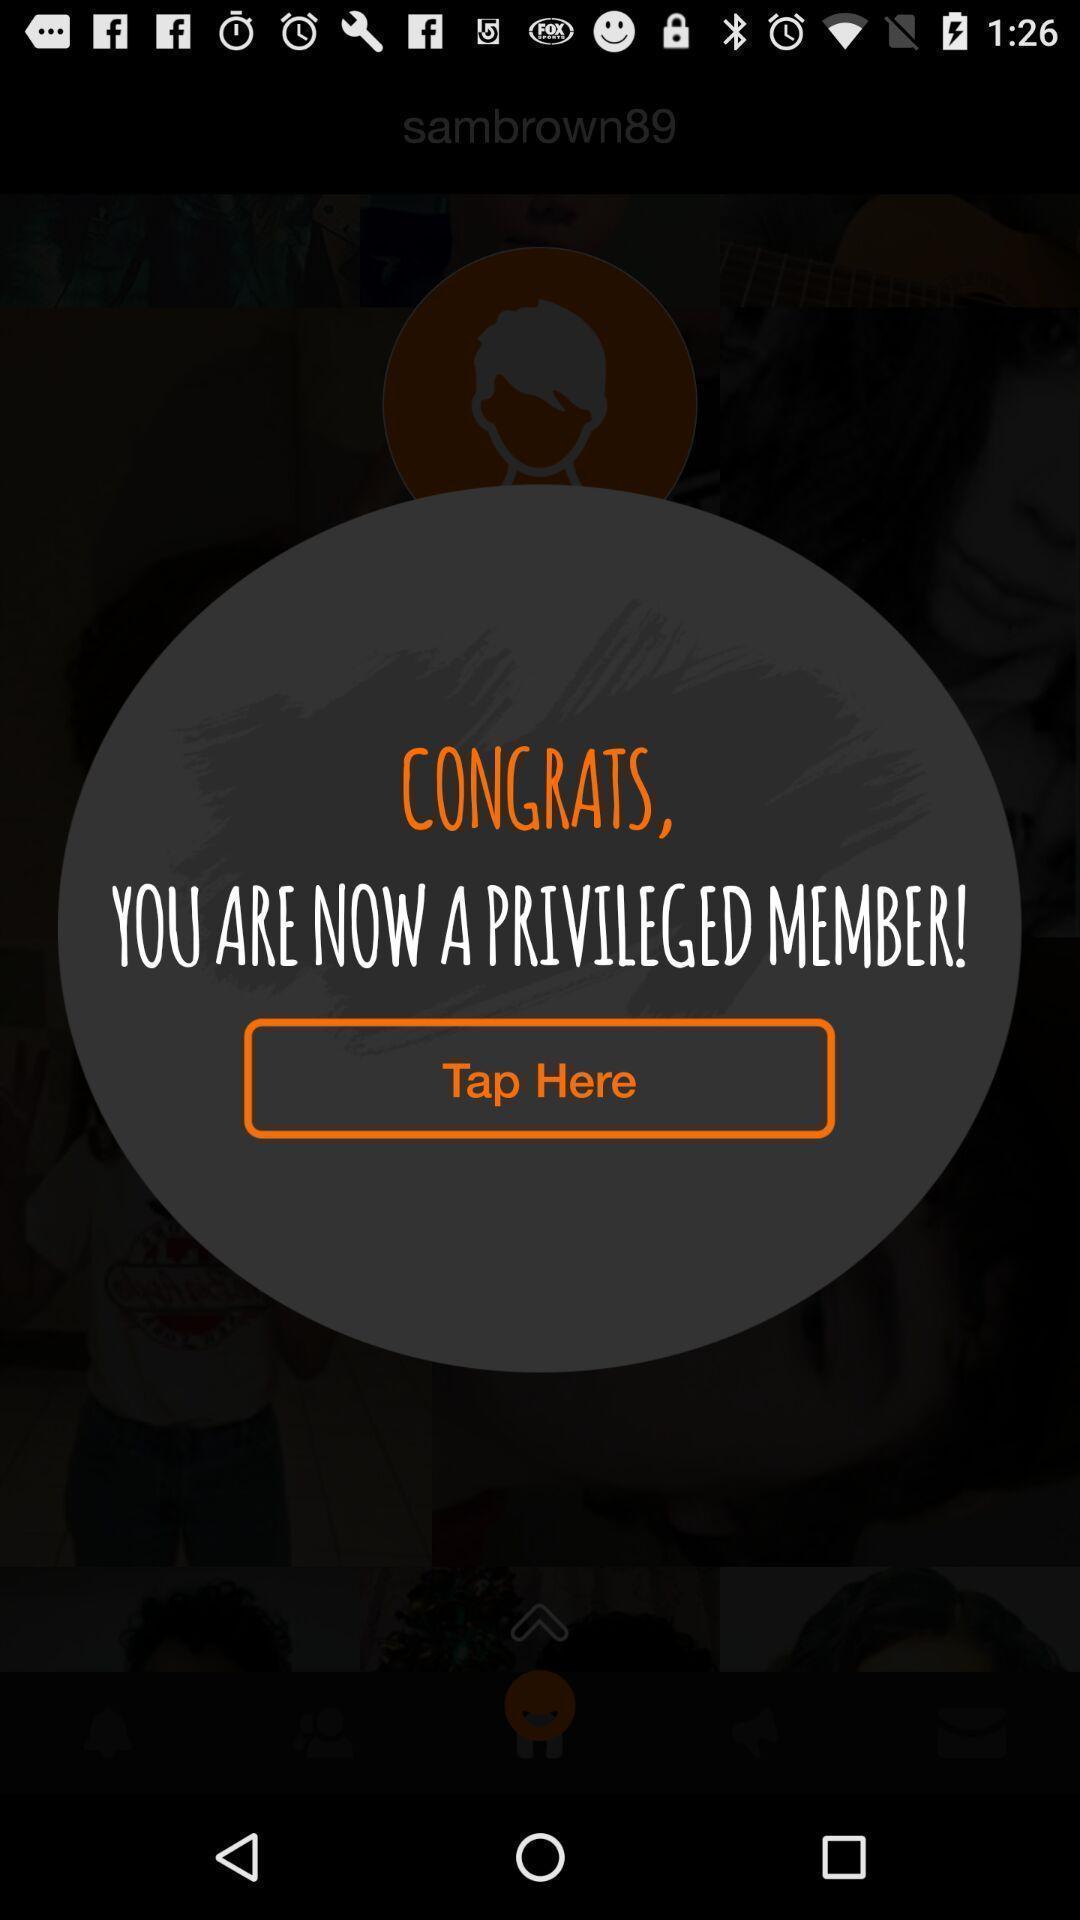Summarize the information in this screenshot. Pop-up shows member details. 